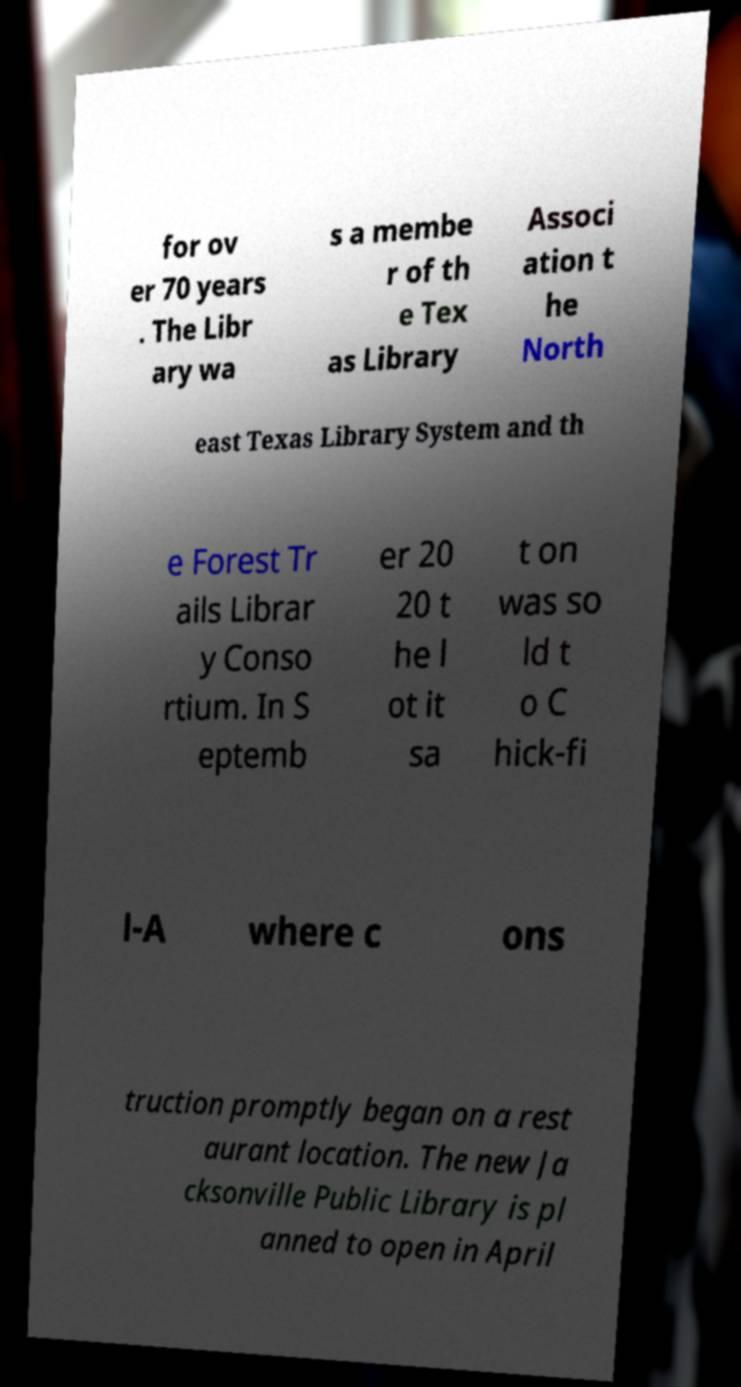Please identify and transcribe the text found in this image. for ov er 70 years . The Libr ary wa s a membe r of th e Tex as Library Associ ation t he North east Texas Library System and th e Forest Tr ails Librar y Conso rtium. In S eptemb er 20 20 t he l ot it sa t on was so ld t o C hick-fi l-A where c ons truction promptly began on a rest aurant location. The new Ja cksonville Public Library is pl anned to open in April 